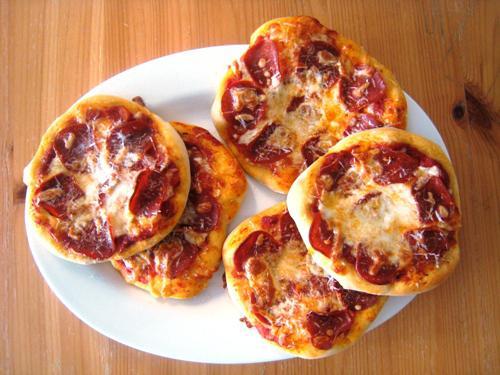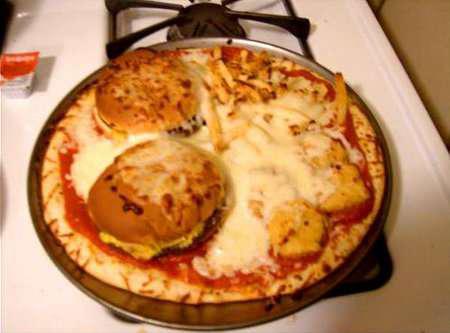The first image is the image on the left, the second image is the image on the right. Given the left and right images, does the statement "A pizza is topped with burgers, fries and nuggets." hold true? Answer yes or no. Yes. The first image is the image on the left, the second image is the image on the right. Considering the images on both sides, is "One of the pizzas has hamburgers on top." valid? Answer yes or no. Yes. 